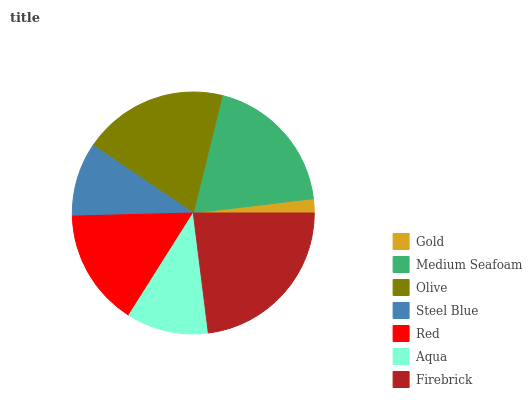Is Gold the minimum?
Answer yes or no. Yes. Is Firebrick the maximum?
Answer yes or no. Yes. Is Medium Seafoam the minimum?
Answer yes or no. No. Is Medium Seafoam the maximum?
Answer yes or no. No. Is Medium Seafoam greater than Gold?
Answer yes or no. Yes. Is Gold less than Medium Seafoam?
Answer yes or no. Yes. Is Gold greater than Medium Seafoam?
Answer yes or no. No. Is Medium Seafoam less than Gold?
Answer yes or no. No. Is Red the high median?
Answer yes or no. Yes. Is Red the low median?
Answer yes or no. Yes. Is Firebrick the high median?
Answer yes or no. No. Is Medium Seafoam the low median?
Answer yes or no. No. 